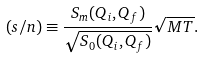<formula> <loc_0><loc_0><loc_500><loc_500>( s / n ) \equiv \frac { S _ { m } ( Q _ { i } , Q _ { f } ) } { \sqrt { S _ { 0 } ( Q _ { i } , Q _ { f } ) } } \sqrt { M T } .</formula> 